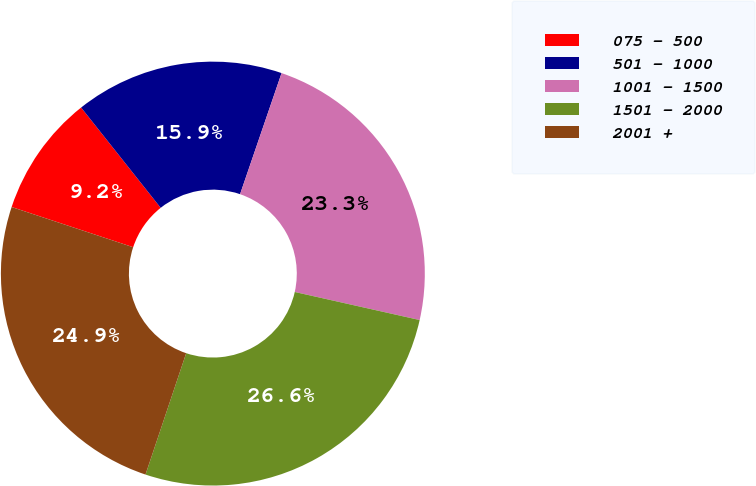<chart> <loc_0><loc_0><loc_500><loc_500><pie_chart><fcel>075 - 500<fcel>501 - 1000<fcel>1001 - 1500<fcel>1501 - 2000<fcel>2001 +<nl><fcel>9.24%<fcel>15.93%<fcel>23.26%<fcel>26.63%<fcel>24.94%<nl></chart> 